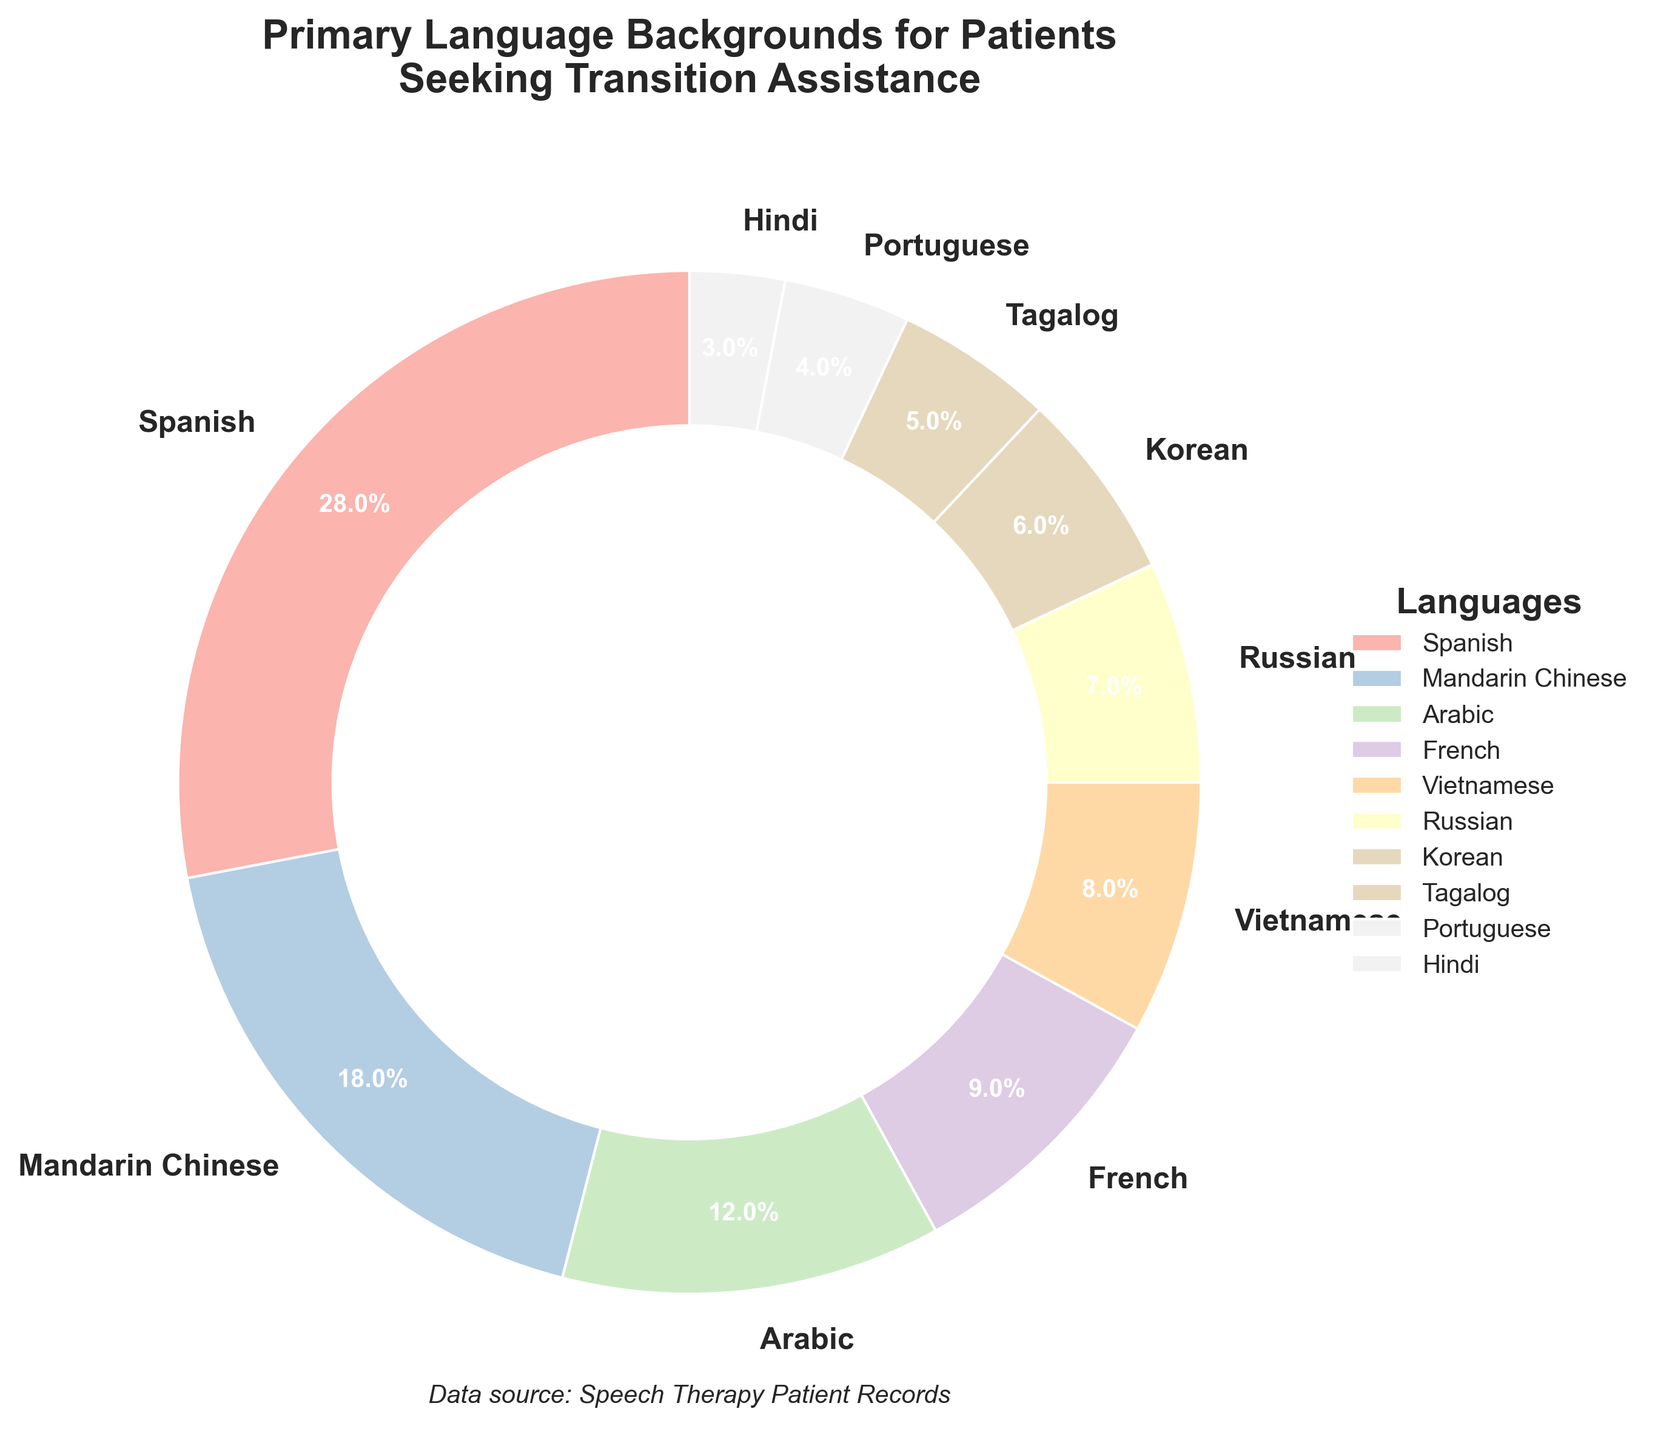Which language has the highest percentage of patients seeking transition assistance? The figure shows the breakdown of primary language backgrounds. The language with the largest wedge in the pie chart corresponds to the highest percentage.
Answer: Spanish How many languages have a percentage of 10% or higher? Examine the pie chart and identify the labels with percentages 10% or more. There are three such languages: Spanish, Mandarin Chinese, and Arabic.
Answer: 3 Which language has the lowest percentage of patients seeking transition assistance? The pie chart shows the breakdown and the smallest wedge corresponds to the lowest percentage.
Answer: Hindi What is the combined percentage of patients speaking Mandarin Chinese and Spanish? Sum the percentages of Mandarin Chinese (18%) and Spanish (28%) by locating them on the chart. 18 + 28 = 46
Answer: 46% Which language group is slightly larger, French or Vietnamese, and by how much? Compare the wedges for French and Vietnamese in the pie chart. French is at 9% and Vietnamese is at 8%, hence the difference is 1%.
Answer: French by 1% Are the combined percentages of Russian and Korean greater than Spanish? Add the percentages of Russian (7%) and Korean (6%) and compare their sum (7% + 6% = 13%) to Spanish (28%). 13% is less than 28%, so the combined is not greater than Spanish.
Answer: No How many languages have a percentage between 5% and 10%? Identify the pie chart wedges with percentages between 5% and 10%. They are French (9%), Vietnamese (8%), Russian (7%), Korean (6%), and Tagalog (5%). There are five such languages.
Answer: 5 What is the average percentage of the languages that have more than 10% of patients seeking assistance? Add the percentages of the applicable languages: Spanish (28%), Mandarin Chinese (18%), and Arabic (12%). Sum = 28 + 18 + 12 = 58. Divide by 3 to find the average: 58 / 3 ≈ 19.33
Answer: 19.33% Is the percentage of Arabic-speaking patients more or less than half the percentage of Spanish-speaking patients? The percentage for Arabic is 12% and for Spanish is 28%. Calculate half of Spanish (28 / 2 = 14). Since 12% is less than 14%, Arabic is less than half.
Answer: Less If the combined percentage of the bottom four languages were represented as a single group, would this new group exceed the percentage of Mandarin Chinese? Add the percentages of Tagalog (5%), Portuguese (4%), Hindi (3%), and Korean (6%). Sum = 5 + 4 + 3 + 6 = 18. These match the Mandarin Chinese percentage of 18%, so they do not exceed it.
Answer: No 